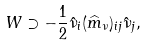Convert formula to latex. <formula><loc_0><loc_0><loc_500><loc_500>W \supset - \frac { 1 } { 2 } \hat { \nu } _ { i } ( \widehat { m } _ { \nu } ) _ { i j } \hat { \nu } _ { j } ,</formula> 